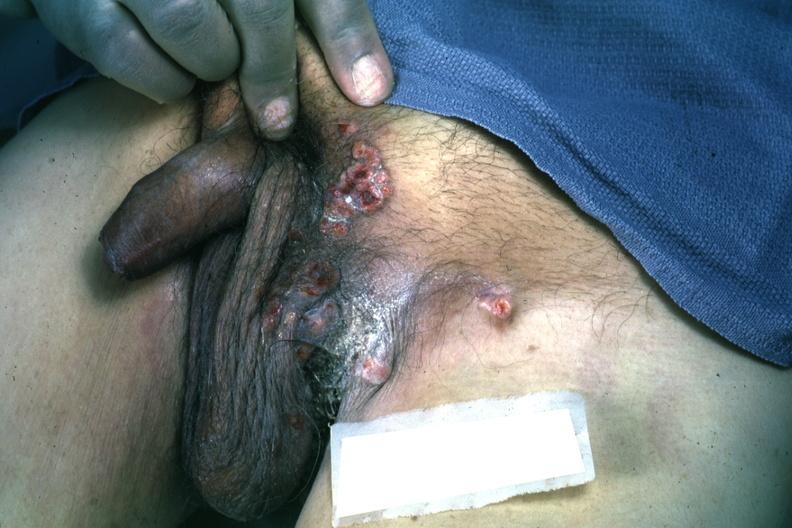does cachexia show multiple ulcerative lesions rectum primary excellent?
Answer the question using a single word or phrase. No 